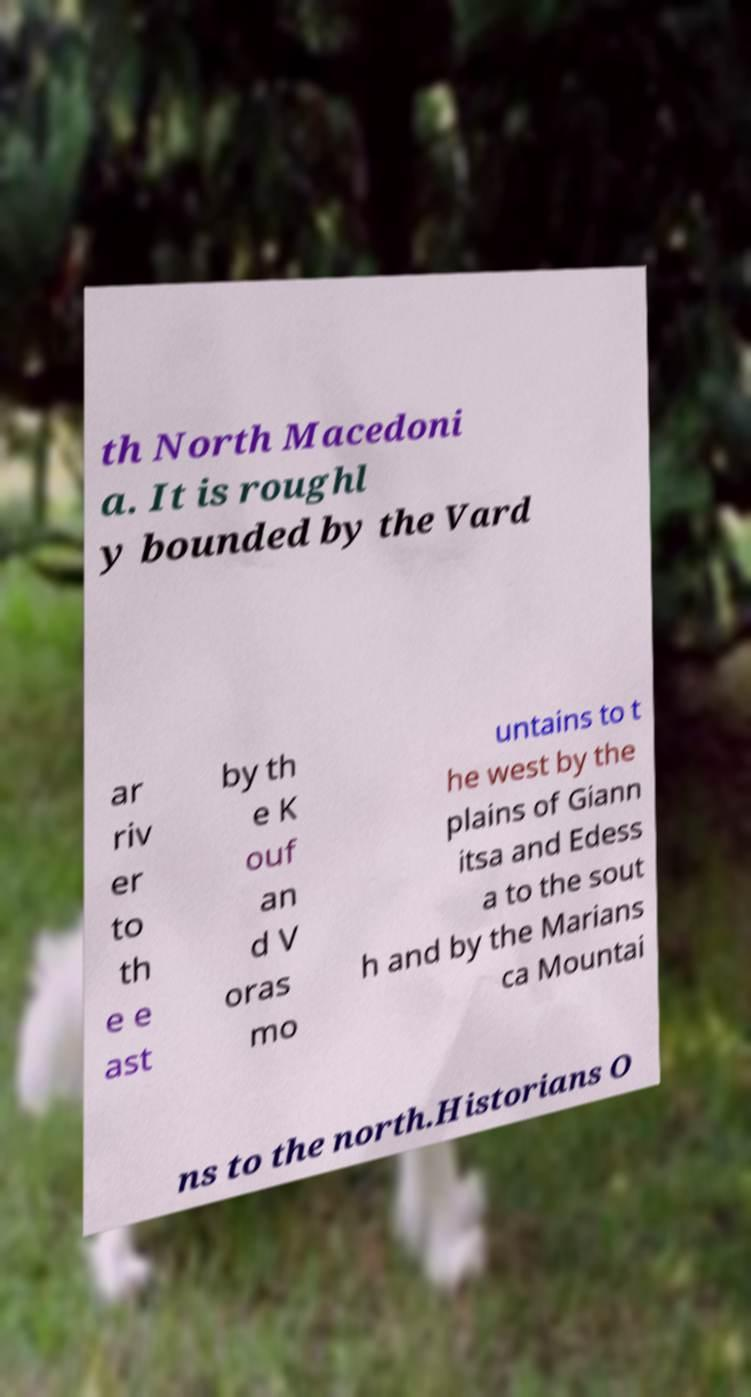Can you read and provide the text displayed in the image?This photo seems to have some interesting text. Can you extract and type it out for me? th North Macedoni a. It is roughl y bounded by the Vard ar riv er to th e e ast by th e K ouf an d V oras mo untains to t he west by the plains of Giann itsa and Edess a to the sout h and by the Marians ca Mountai ns to the north.Historians O 